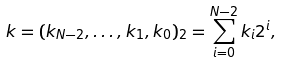<formula> <loc_0><loc_0><loc_500><loc_500>k = ( k _ { N - 2 } , \dots , k _ { 1 } , k _ { 0 } ) _ { 2 } = \sum _ { i = 0 } ^ { N - 2 } k _ { i } 2 ^ { i } ,</formula> 